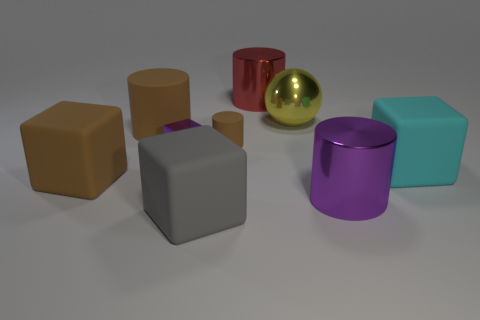Subtract all red shiny cylinders. How many cylinders are left? 3 Add 1 tiny blocks. How many objects exist? 10 Subtract all cyan blocks. How many blocks are left? 3 Subtract all gray spheres. How many brown cylinders are left? 2 Subtract all cubes. How many objects are left? 5 Subtract 2 cylinders. How many cylinders are left? 2 Subtract 0 green cubes. How many objects are left? 9 Subtract all brown cubes. Subtract all blue cylinders. How many cubes are left? 3 Subtract all red metallic cylinders. Subtract all yellow objects. How many objects are left? 7 Add 5 purple cylinders. How many purple cylinders are left? 6 